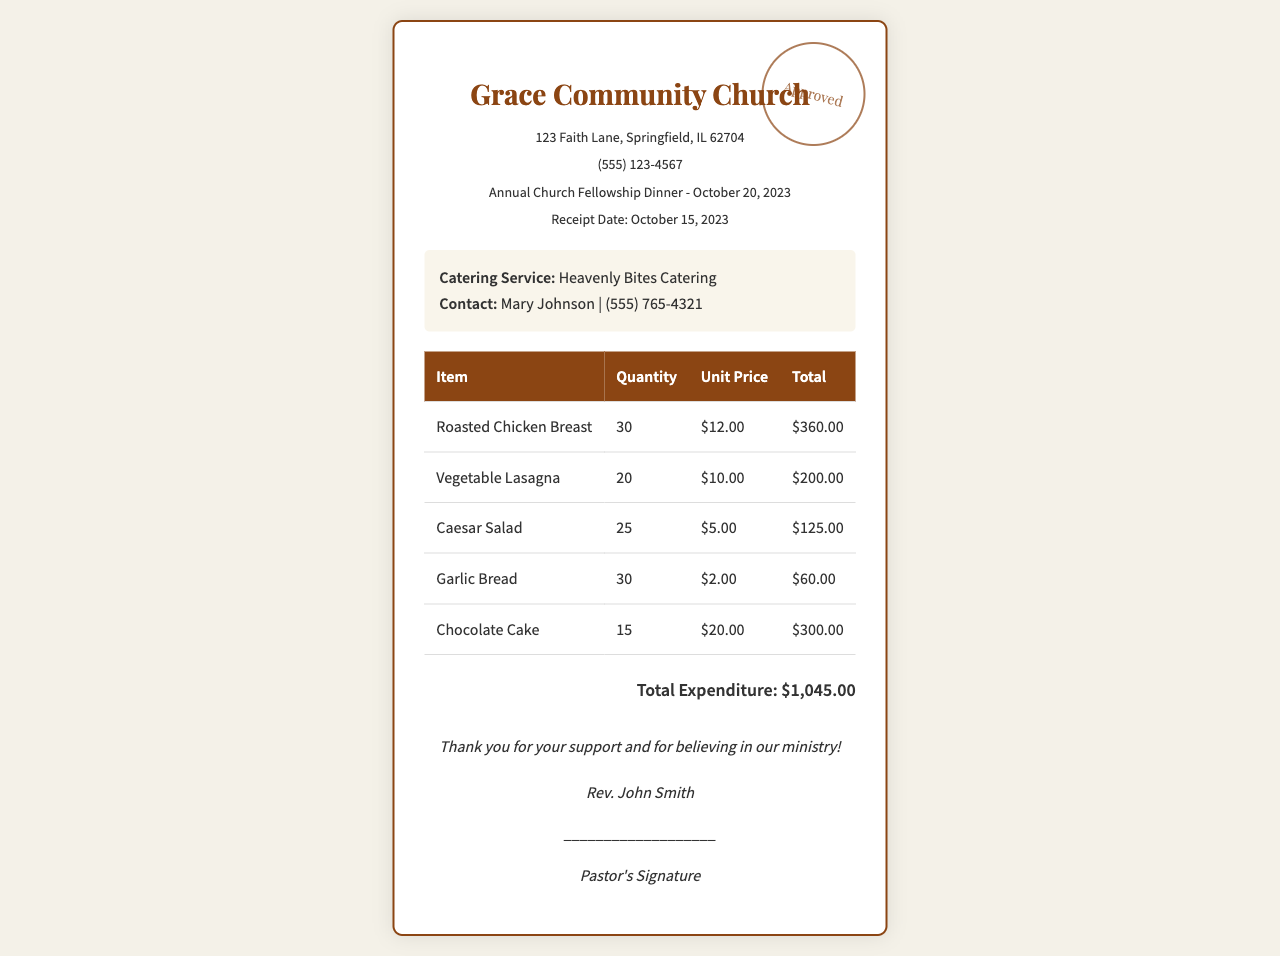What is the name of the church? The name of the church is mentioned in the heading of the document.
Answer: Grace Community Church What is the total expenditure? The total expenditure is found at the bottom of the receipt.
Answer: $1,045.00 How many Roasted Chicken Breasts were ordered? The quantity of Roasted Chicken Breasts is noted in the itemized list.
Answer: 30 Who is the catering service provider? The catering service provider is specified in the catering information section.
Answer: Heavenly Bites Catering On what date did the event take place? The date of the event is mentioned in the event information section.
Answer: October 20, 2023 What is the unit price of Vegetable Lasagna? The unit price of Vegetable Lasagna is found in the itemized list.
Answer: $10.00 How many servings of Chocolate Cake were ordered? The quantity of Chocolate Cake is provided in the table.
Answer: 15 Who signed the receipt? The signature section includes the name of the person who signed the receipt.
Answer: Rev. John Smith What type of dish is Caesar Salad? The document lists Caesar Salad as an item in the menu section, indicating its nature.
Answer: Salad 